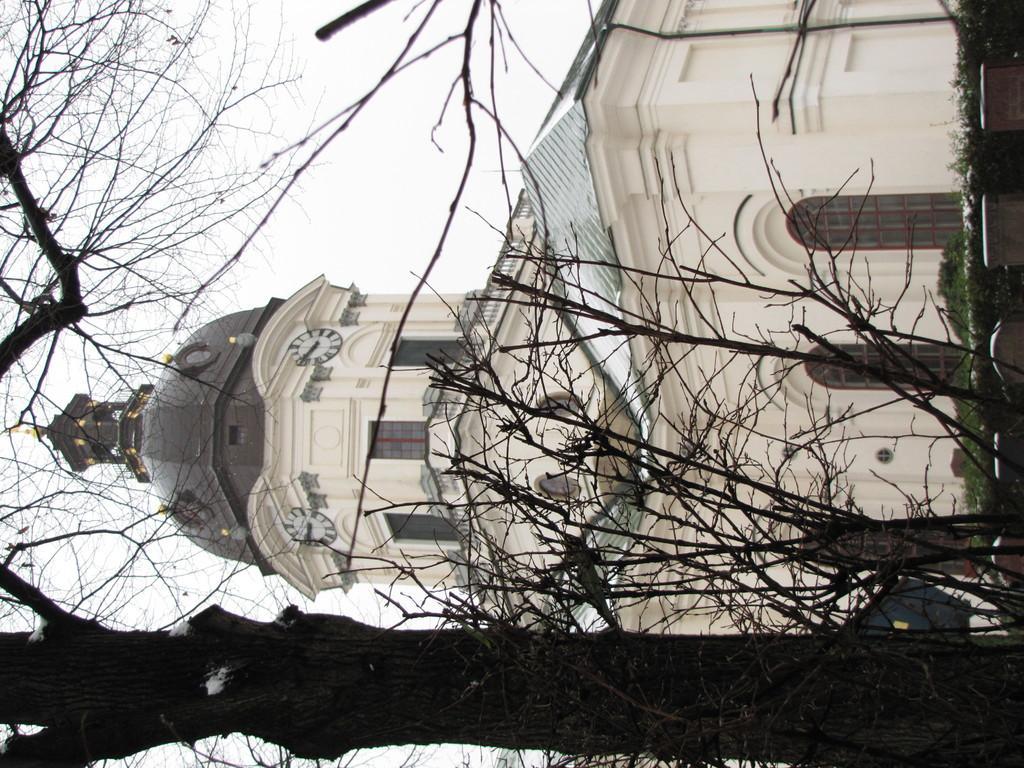Please provide a concise description of this image. In this image there is a building in middle of this image and there is a tree at left side of this image and there is a sky at top left side of this image. 